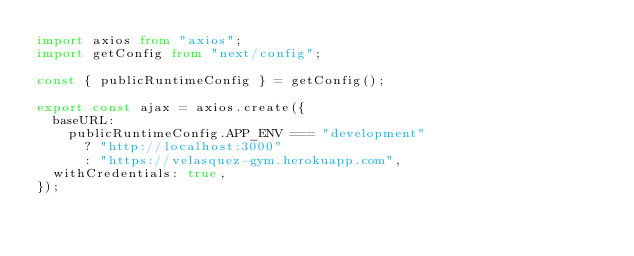<code> <loc_0><loc_0><loc_500><loc_500><_TypeScript_>import axios from "axios";
import getConfig from "next/config";

const { publicRuntimeConfig } = getConfig();

export const ajax = axios.create({
  baseURL:
    publicRuntimeConfig.APP_ENV === "development"
      ? "http://localhost:3000"
      : "https://velasquez-gym.herokuapp.com",
  withCredentials: true,
});
</code> 